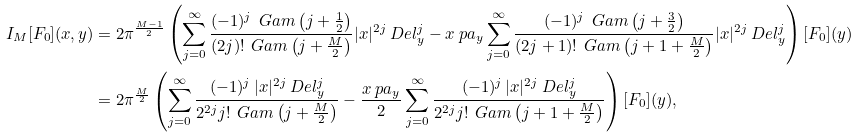Convert formula to latex. <formula><loc_0><loc_0><loc_500><loc_500>I _ { M } [ F _ { 0 } ] ( { x } , { y } ) & = 2 \pi ^ { \frac { M - 1 } { 2 } } \left ( \sum _ { j = 0 } ^ { \infty } \frac { ( - 1 ) ^ { j } \, \ G a m \left ( j + \frac { 1 } { 2 } \right ) } { ( 2 j ) ! \, \ G a m \left ( j + \frac { M } { 2 } \right ) } | { x } | ^ { 2 j } \ D e l _ { y } ^ { j } - { x } \ p a _ { y } \sum _ { j = 0 } ^ { \infty } \frac { ( - 1 ) ^ { j } \, \ G a m \left ( j + \frac { 3 } { 2 } \right ) } { ( 2 j + 1 ) ! \, \ G a m \left ( j + 1 + \frac { M } { 2 } \right ) } | { x } | ^ { 2 j } \ D e l _ { y } ^ { j } \right ) [ F _ { 0 } ] ( { y } ) \\ & = 2 \pi ^ { \frac { M } { 2 } } \left ( \sum _ { j = 0 } ^ { \infty } \frac { ( - 1 ) ^ { j } \, | { x } | ^ { 2 j } \ D e l _ { y } ^ { j } } { 2 ^ { 2 j } j ! \, \ G a m \left ( j + \frac { M } { 2 } \right ) } - \frac { { x } \ p a _ { y } } { 2 } \sum _ { j = 0 } ^ { \infty } \frac { ( - 1 ) ^ { j } \, | { x } | ^ { 2 j } \ D e l _ { y } ^ { j } } { 2 ^ { 2 j } j ! \, \ G a m \left ( j + 1 + \frac { M } { 2 } \right ) } \right ) [ F _ { 0 } ] ( { y } ) ,</formula> 